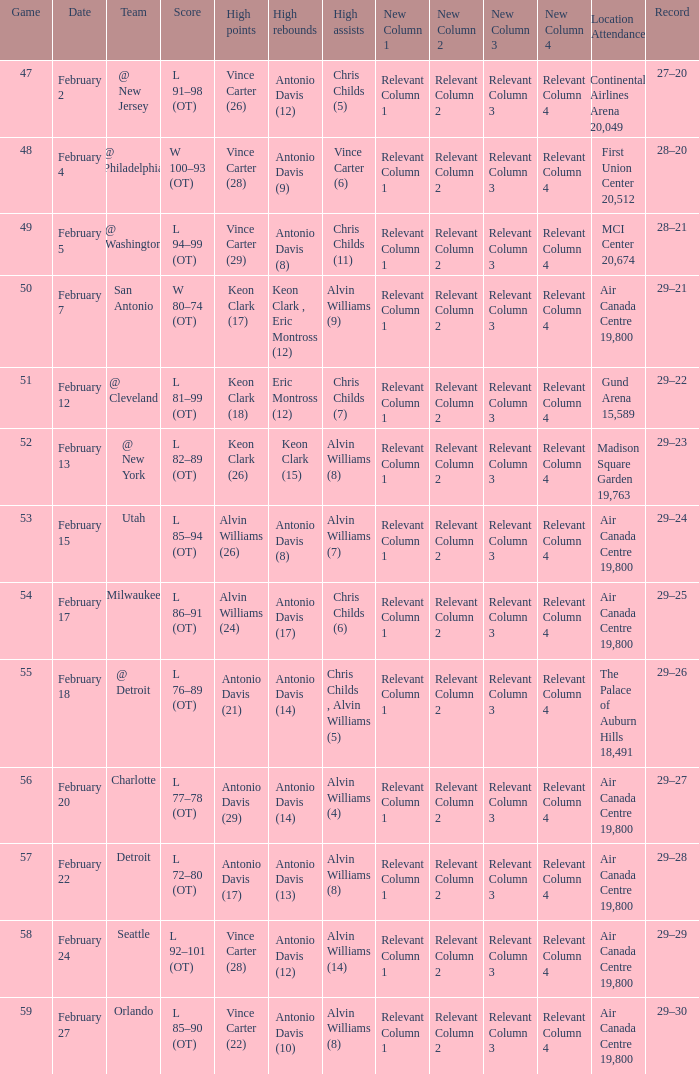What is the Record when the high rebounds was Antonio Davis (9)? 28–20. 